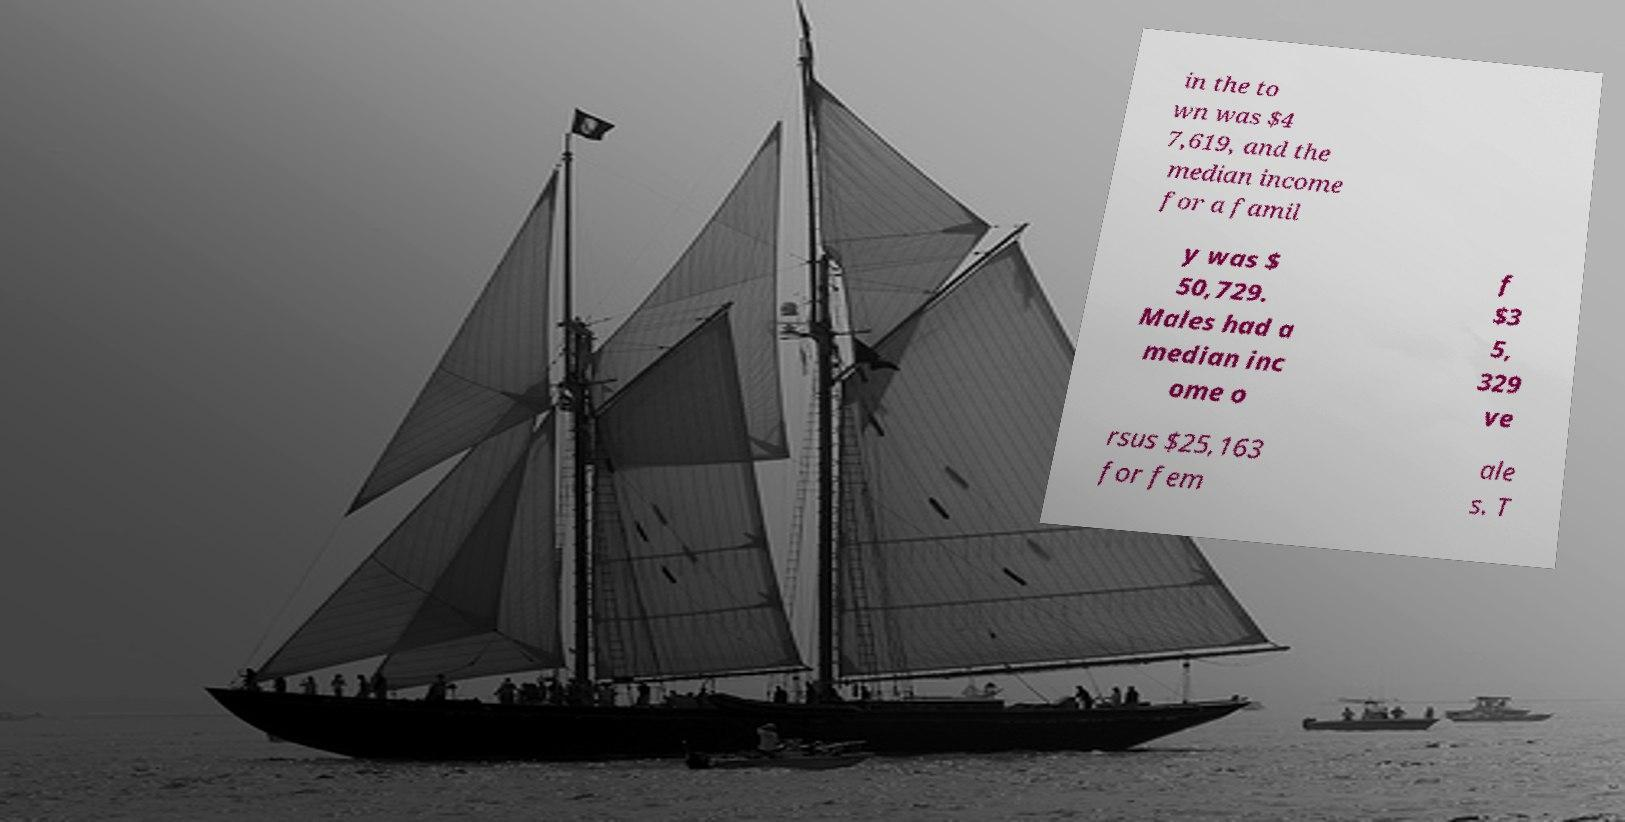What messages or text are displayed in this image? I need them in a readable, typed format. in the to wn was $4 7,619, and the median income for a famil y was $ 50,729. Males had a median inc ome o f $3 5, 329 ve rsus $25,163 for fem ale s. T 